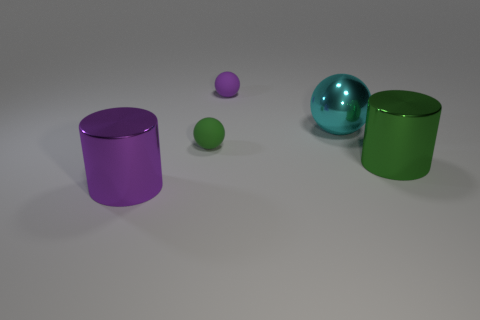How many cyan metal things are the same size as the purple shiny cylinder?
Your answer should be very brief. 1. There is a cylinder to the right of the large sphere; how many green shiny cylinders are on the right side of it?
Provide a succinct answer. 0. There is a green thing left of the cylinder right of the large purple cylinder; are there any cyan things that are in front of it?
Make the answer very short. No. There is a big thing that is both on the right side of the green rubber ball and in front of the small green rubber object; what is its shape?
Ensure brevity in your answer.  Cylinder. What color is the metal cylinder on the right side of the big thing on the left side of the shiny ball?
Offer a very short reply. Green. What is the size of the cylinder to the right of the large cylinder to the left of the big cylinder right of the purple cylinder?
Provide a short and direct response. Large. Does the large cyan ball have the same material as the green thing that is in front of the small green rubber ball?
Give a very brief answer. Yes. The purple thing that is the same material as the tiny green object is what size?
Your answer should be compact. Small. Is there another metal object of the same shape as the large green thing?
Offer a very short reply. Yes. How many objects are either objects that are left of the tiny green matte thing or purple shiny things?
Provide a short and direct response. 1. 